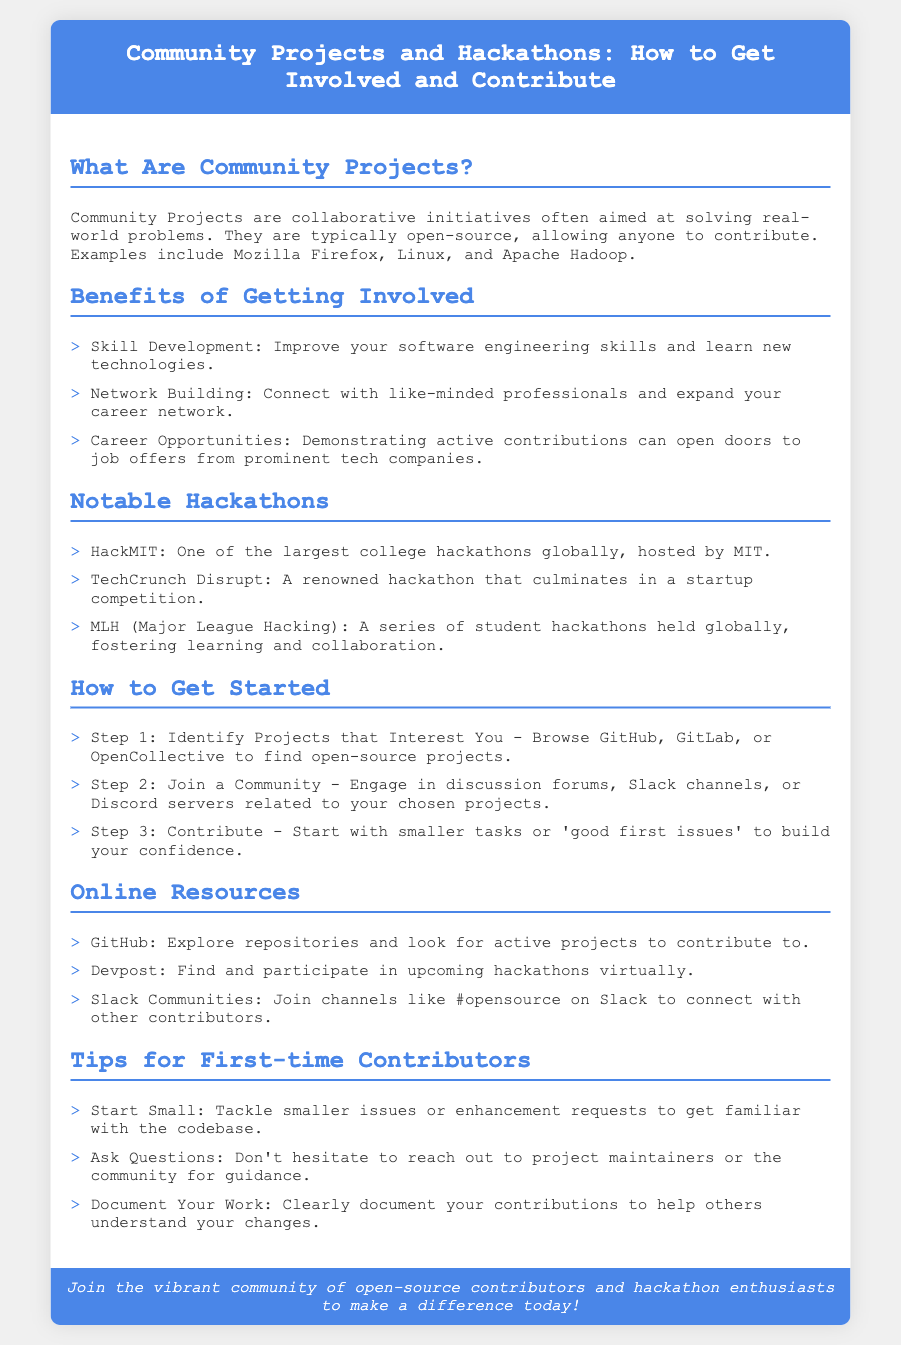What are Community Projects? Community Projects are collaborative initiatives often aimed at solving real-world problems.
Answer: Collaborative initiatives What are two notable hackathons mentioned? The document lists notable hackathons, two of which are HackMIT and TechCrunch Disrupt.
Answer: HackMIT, TechCrunch Disrupt What is the first step to get started in community projects? The first step to get started is to identify projects that interest you.
Answer: Identify projects that interest you What platform can be used to explore repositories? One of the online resources for exploring repositories is GitHub.
Answer: GitHub What should first-time contributors do with their work? First-time contributors should clearly document their contributions.
Answer: Document your work What can demonstrate active contributions? Demonstrating active contributions can open doors to job offers.
Answer: Job offers What is one benefit of joining a community? One benefit is network building.
Answer: Network building How many steps are listed to get started? The document outlines three steps to get started.
Answer: Three steps 